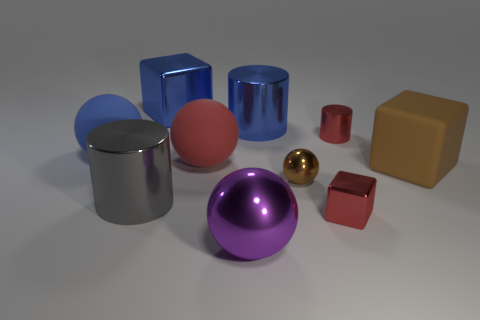Subtract 1 balls. How many balls are left? 3 Subtract all balls. How many objects are left? 6 Subtract all yellow spheres. Subtract all big brown things. How many objects are left? 9 Add 1 blue metallic cubes. How many blue metallic cubes are left? 2 Add 9 tiny metallic cylinders. How many tiny metallic cylinders exist? 10 Subtract 1 red spheres. How many objects are left? 9 